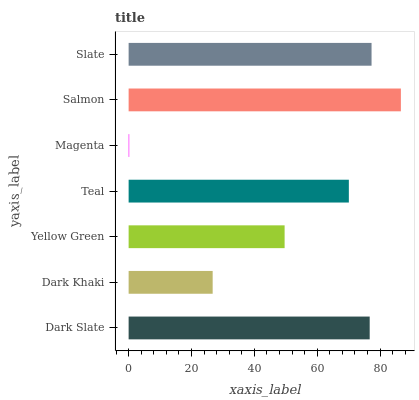Is Magenta the minimum?
Answer yes or no. Yes. Is Salmon the maximum?
Answer yes or no. Yes. Is Dark Khaki the minimum?
Answer yes or no. No. Is Dark Khaki the maximum?
Answer yes or no. No. Is Dark Slate greater than Dark Khaki?
Answer yes or no. Yes. Is Dark Khaki less than Dark Slate?
Answer yes or no. Yes. Is Dark Khaki greater than Dark Slate?
Answer yes or no. No. Is Dark Slate less than Dark Khaki?
Answer yes or no. No. Is Teal the high median?
Answer yes or no. Yes. Is Teal the low median?
Answer yes or no. Yes. Is Slate the high median?
Answer yes or no. No. Is Salmon the low median?
Answer yes or no. No. 